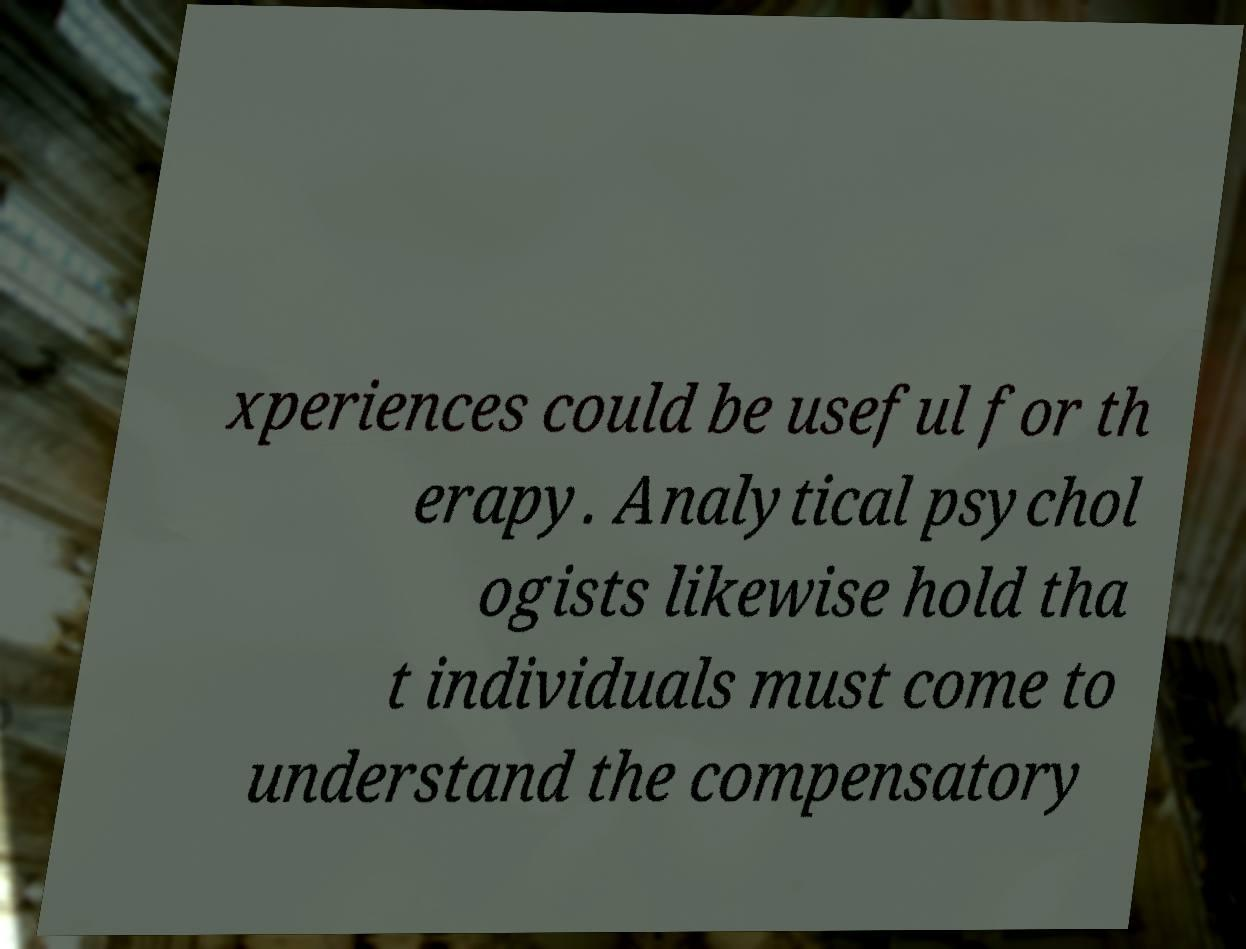Can you accurately transcribe the text from the provided image for me? xperiences could be useful for th erapy. Analytical psychol ogists likewise hold tha t individuals must come to understand the compensatory 